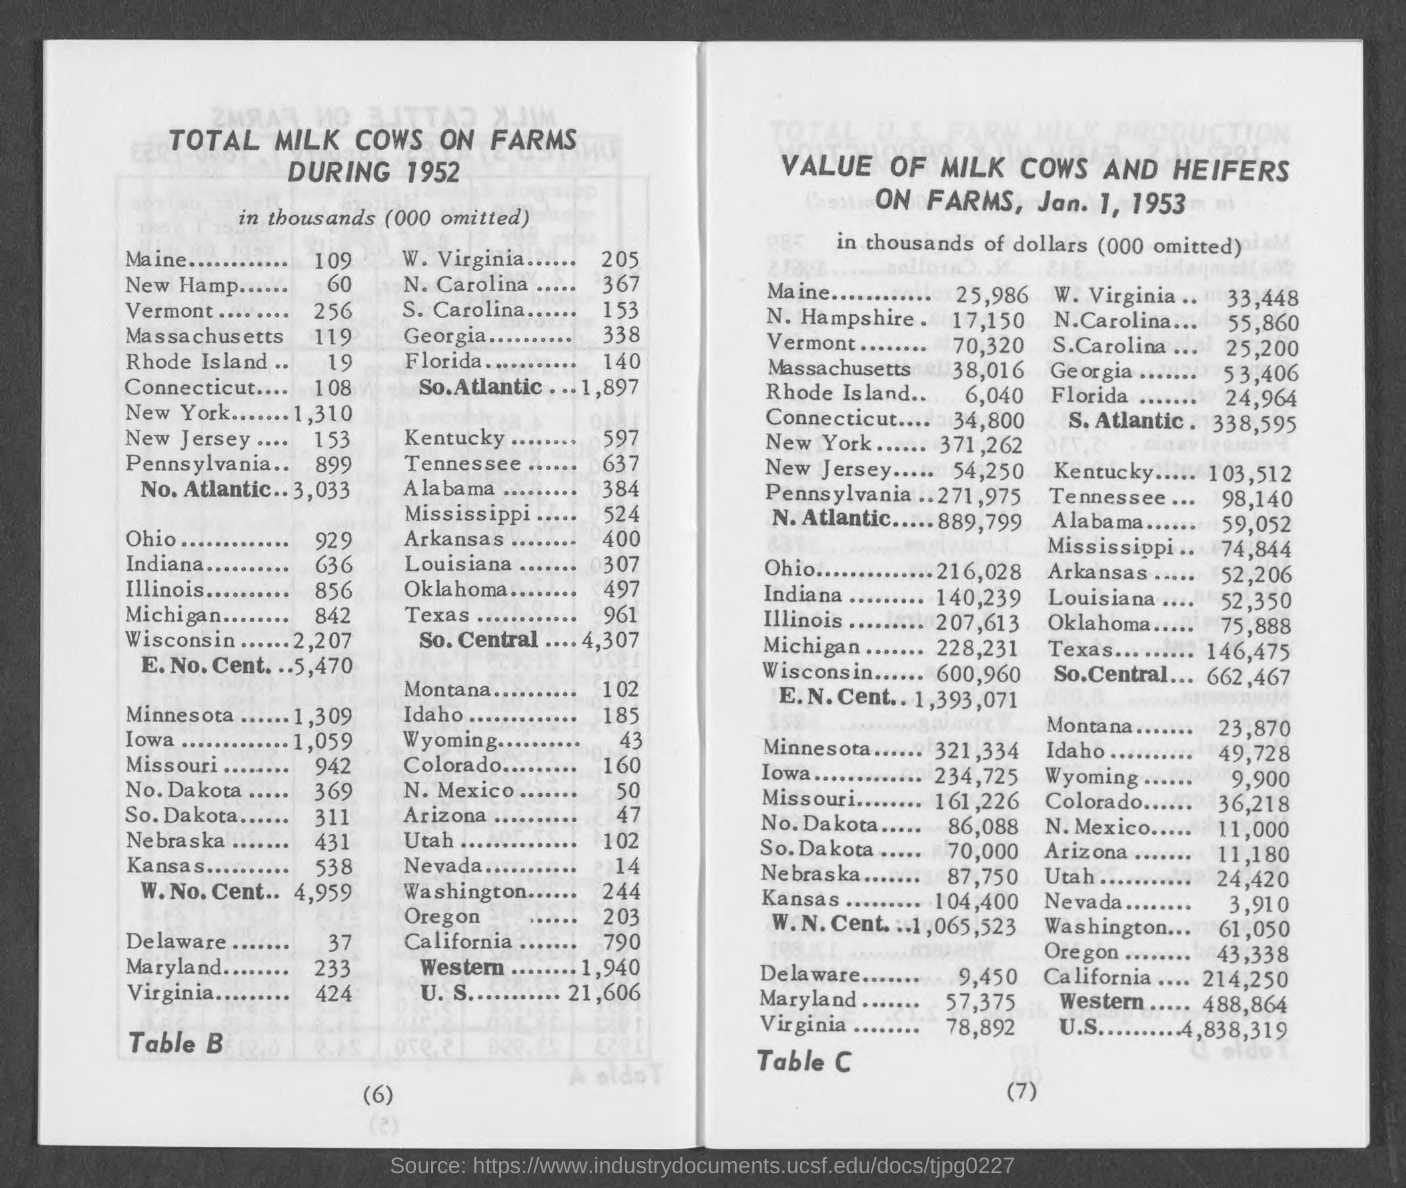Highlight a few significant elements in this photo. In Massachusetts during 1952, there were approximately 119 thousand milk cows on farms. During the year 1952, there were approximately 60 thousand milk cows on farms in New Hampshire. In 1952, the total number of milk cows on farms in Ohio was 929 thousand. There were approximately 153,000 milk cows on farms in New Jersey during the year 1952. During the year 1952, there were approximately 899 thousand milk cows on farms in Pennsylvania. 